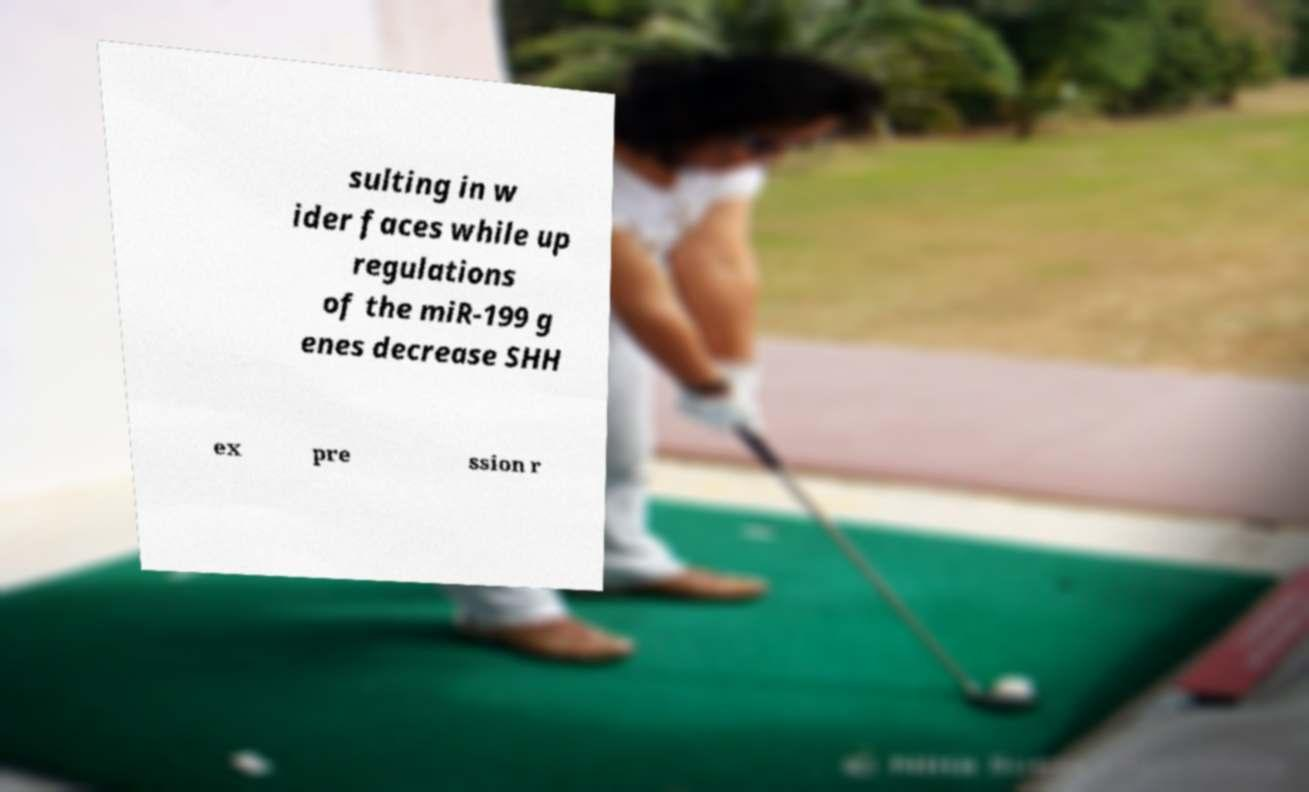What messages or text are displayed in this image? I need them in a readable, typed format. sulting in w ider faces while up regulations of the miR-199 g enes decrease SHH ex pre ssion r 